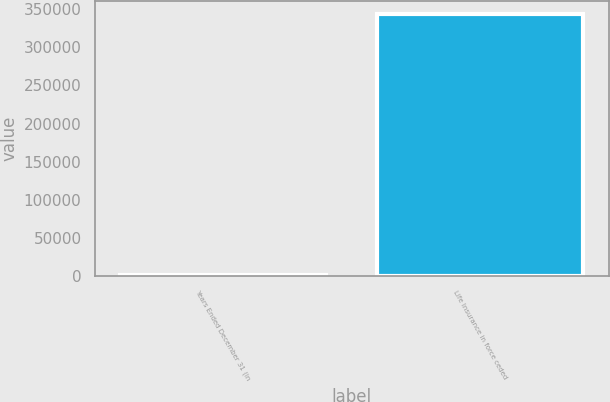Convert chart. <chart><loc_0><loc_0><loc_500><loc_500><bar_chart><fcel>Years Ended December 31 (in<fcel>Life Insurance in force ceded<nl><fcel>2004<fcel>344036<nl></chart> 